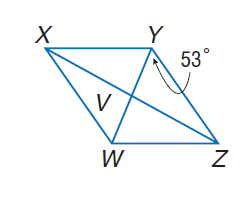Answer the mathemtical geometry problem and directly provide the correct option letter.
Question: Use rhombus X Y Z W with m \angle W Y Z = 53, V W = 3, X V = 2 a - 2, and Z V = \frac { 5 a + 1 } { 4 }. Find X W.
Choices: A: 5 B: 10 C: 15 D: 20 A 